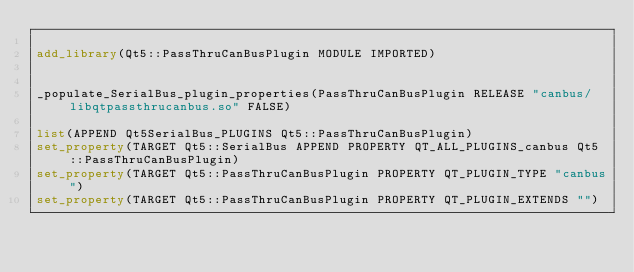<code> <loc_0><loc_0><loc_500><loc_500><_CMake_>
add_library(Qt5::PassThruCanBusPlugin MODULE IMPORTED)


_populate_SerialBus_plugin_properties(PassThruCanBusPlugin RELEASE "canbus/libqtpassthrucanbus.so" FALSE)

list(APPEND Qt5SerialBus_PLUGINS Qt5::PassThruCanBusPlugin)
set_property(TARGET Qt5::SerialBus APPEND PROPERTY QT_ALL_PLUGINS_canbus Qt5::PassThruCanBusPlugin)
set_property(TARGET Qt5::PassThruCanBusPlugin PROPERTY QT_PLUGIN_TYPE "canbus")
set_property(TARGET Qt5::PassThruCanBusPlugin PROPERTY QT_PLUGIN_EXTENDS "")
</code> 